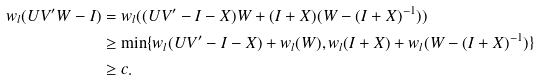Convert formula to latex. <formula><loc_0><loc_0><loc_500><loc_500>w _ { l } ( U V ^ { \prime } W - I ) & = w _ { l } ( ( U V ^ { \prime } - I - X ) W + ( I + X ) ( W - ( I + X ) ^ { - 1 } ) ) \\ & \geq \min \{ w _ { l } ( U V ^ { \prime } - I - X ) + w _ { l } ( W ) , w _ { l } ( I + X ) + w _ { l } ( W - ( I + X ) ^ { - 1 } ) \} \\ & \geq c .</formula> 